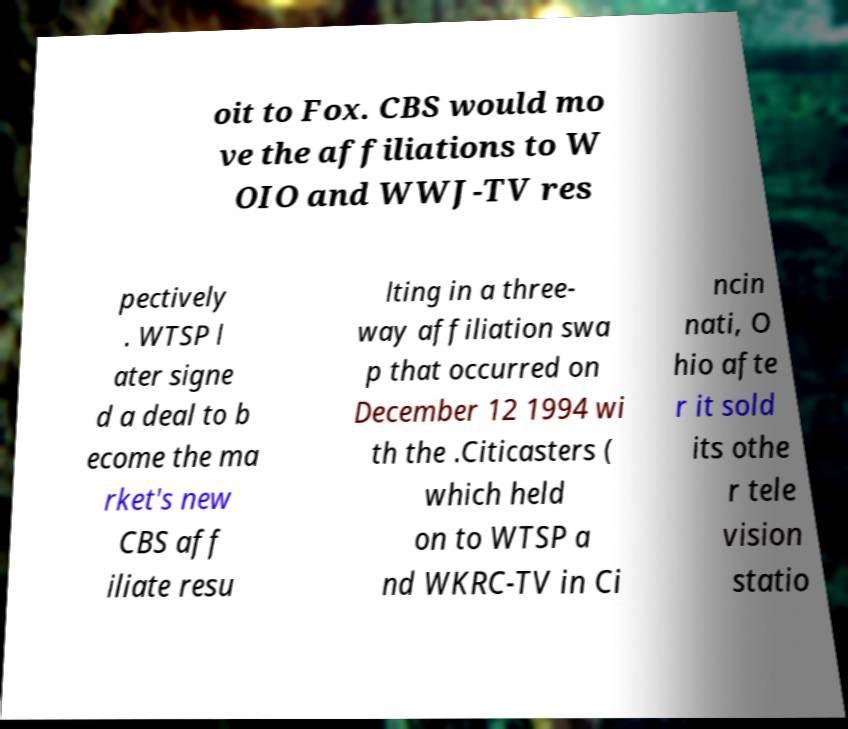I need the written content from this picture converted into text. Can you do that? oit to Fox. CBS would mo ve the affiliations to W OIO and WWJ-TV res pectively . WTSP l ater signe d a deal to b ecome the ma rket's new CBS aff iliate resu lting in a three- way affiliation swa p that occurred on December 12 1994 wi th the .Citicasters ( which held on to WTSP a nd WKRC-TV in Ci ncin nati, O hio afte r it sold its othe r tele vision statio 